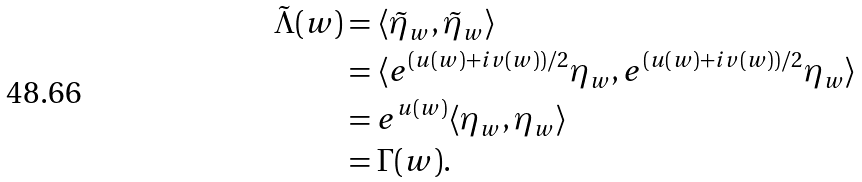<formula> <loc_0><loc_0><loc_500><loc_500>\tilde { \Lambda } ( w ) & = \langle { \tilde { \eta } _ { w } , \tilde { \eta } _ { w } \rangle } \\ & = \langle { e ^ { ( u ( w ) + i v ( w ) ) / 2 } { \eta } _ { w } , e ^ { ( u ( w ) + i v ( w ) ) / 2 } { \eta } _ { w } \rangle } \\ & = e ^ { u ( w ) } \langle { { \eta } _ { w } , { \eta } _ { w } \rangle } \\ & = \Gamma ( w ) .</formula> 